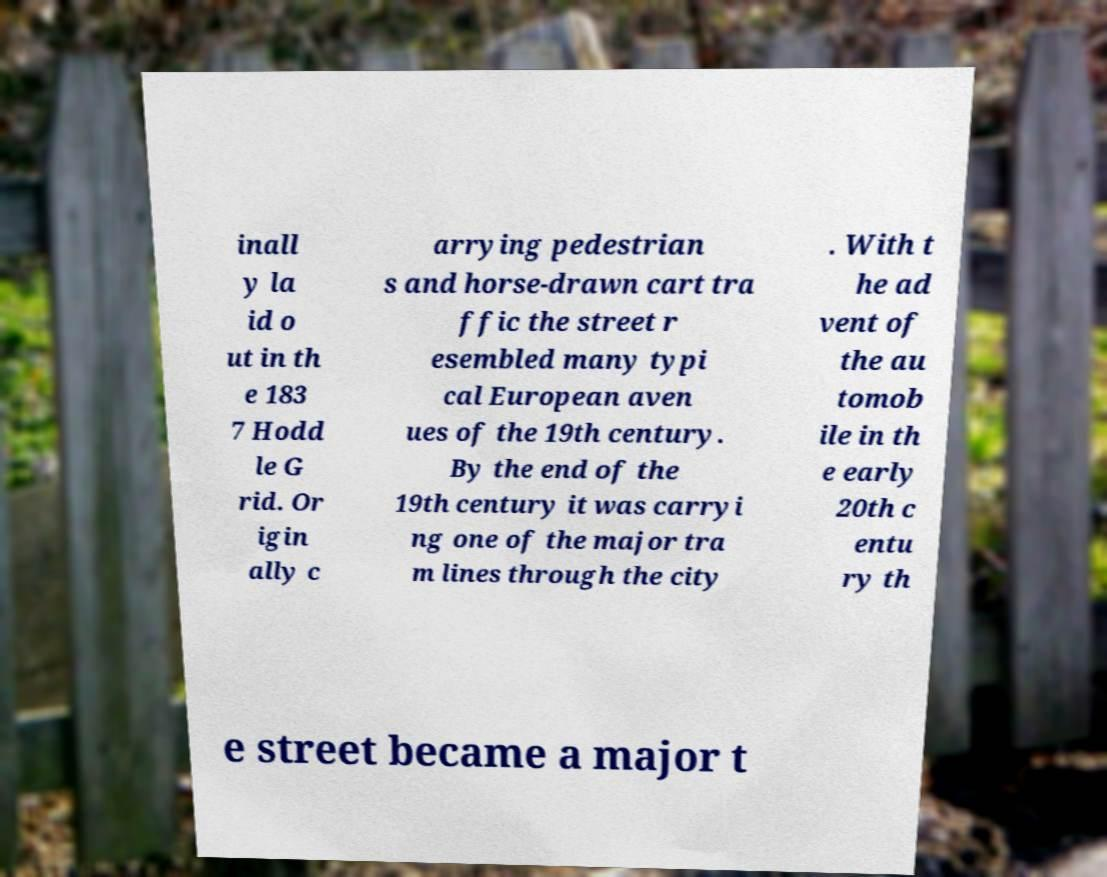For documentation purposes, I need the text within this image transcribed. Could you provide that? inall y la id o ut in th e 183 7 Hodd le G rid. Or igin ally c arrying pedestrian s and horse-drawn cart tra ffic the street r esembled many typi cal European aven ues of the 19th century. By the end of the 19th century it was carryi ng one of the major tra m lines through the city . With t he ad vent of the au tomob ile in th e early 20th c entu ry th e street became a major t 